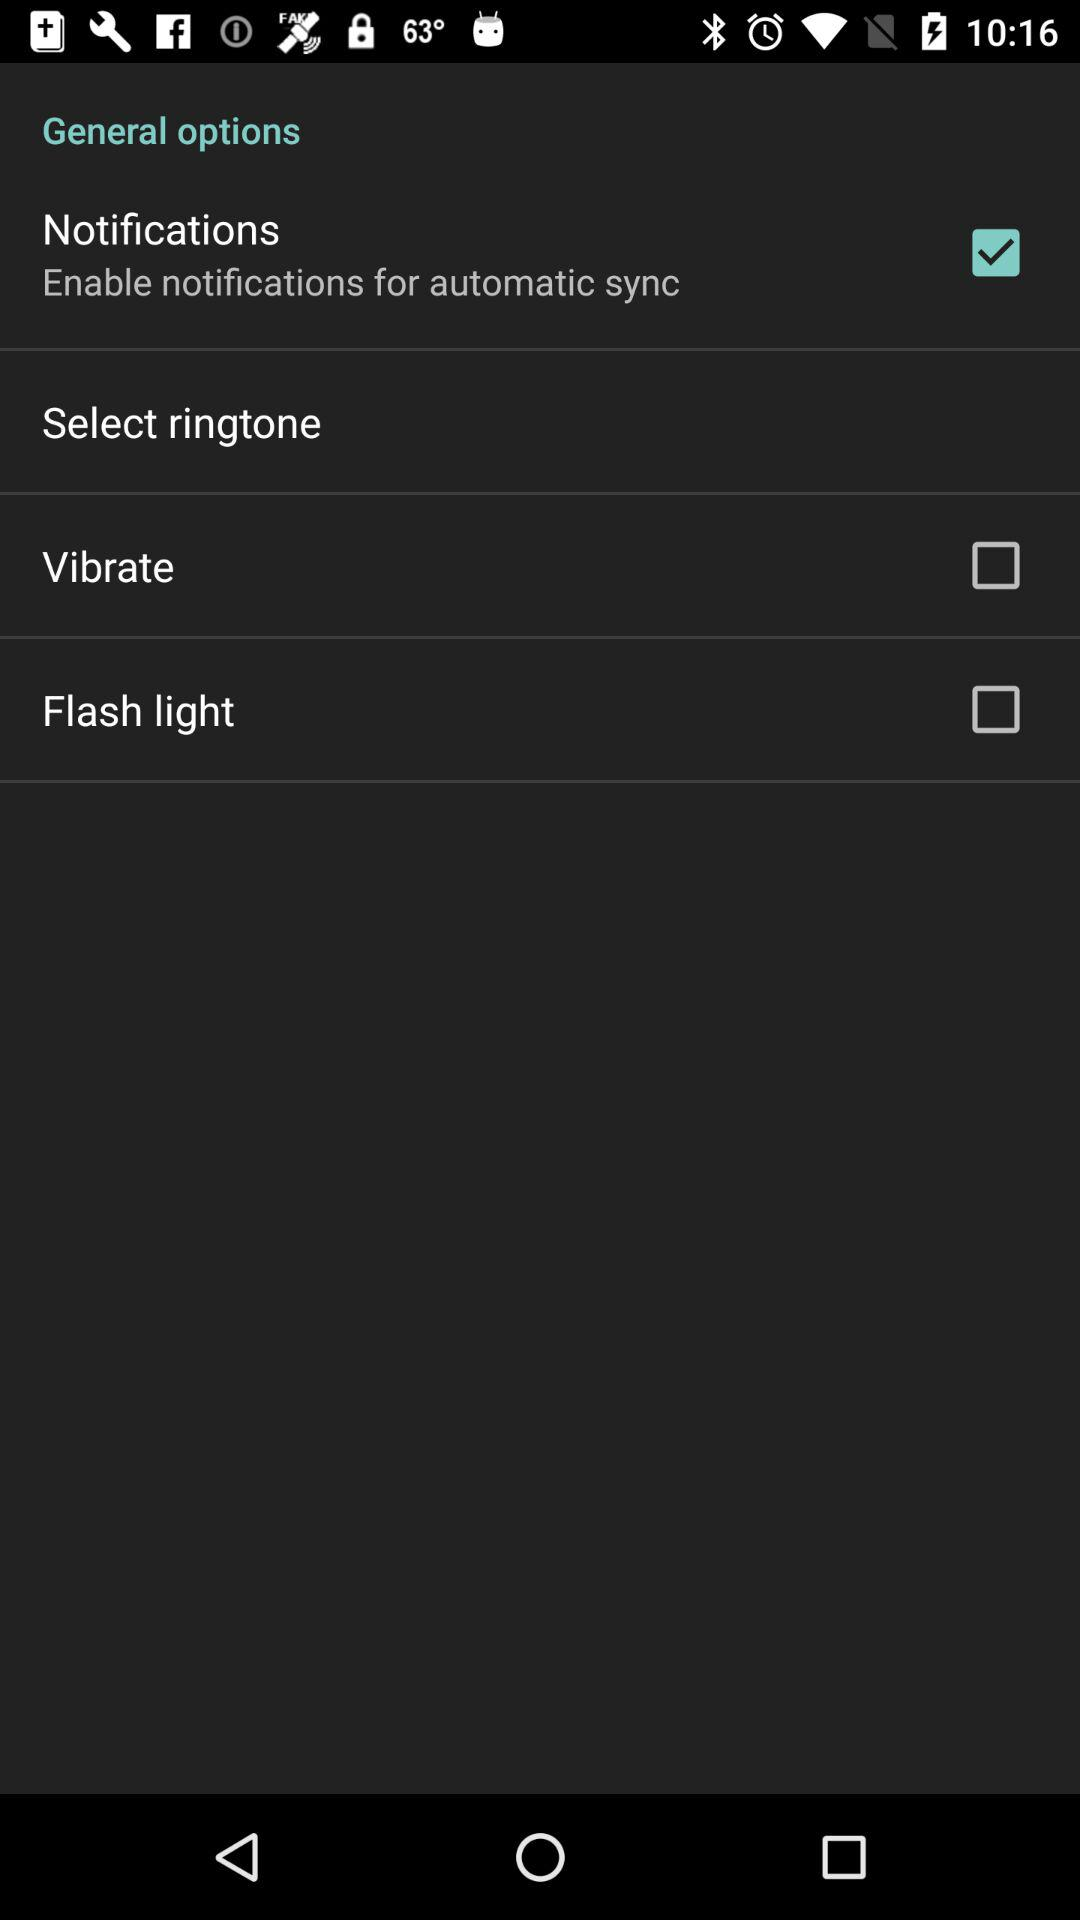What is the current status of vibrate? The status is "off". 